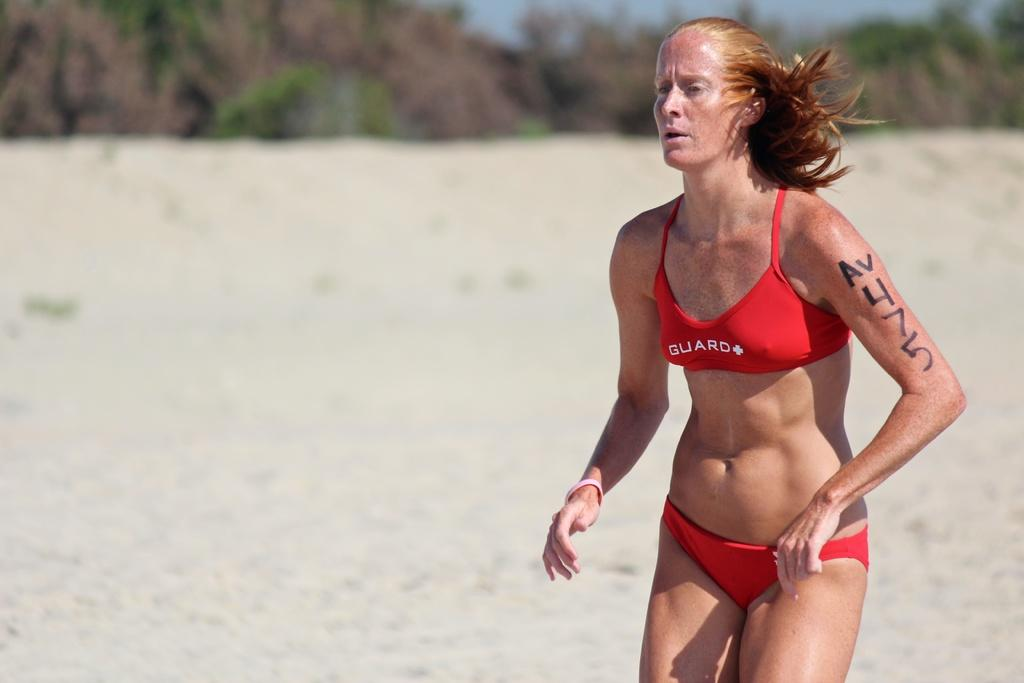<image>
Create a compact narrative representing the image presented. A woman on the beach is wearing a red bathing suit that says Guard. 